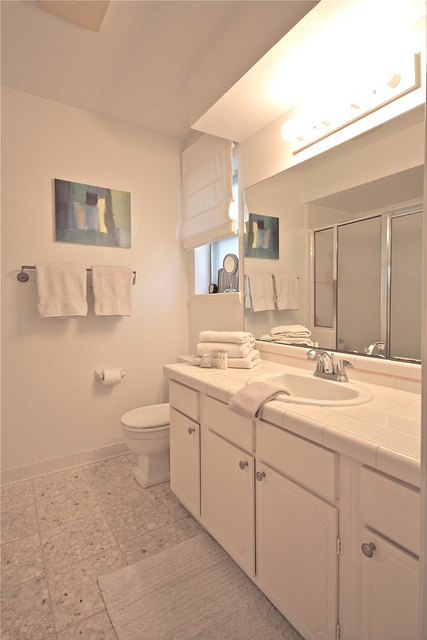What might be the advantages of the bathroom layout?
 The bathroom layout, which features a long white sink and a toilet, appears to be spacious, organized, and functional. One advantage of this layout is that it provides ample space for users to move around comfortably without feeling cramped. The large white sink affords generous counter space for placing toiletries and grooming items, promoting a convenient and efficient experience. Additionally, the color scheme of white cabinets, accessories, and fixtures creates a clean, refreshing atmosphere, which is aesthetically pleasing and contributes to a positive user experience in the bathroom. All these factors together make the bathroom layout both functional and visually appealing. 